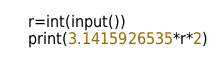<code> <loc_0><loc_0><loc_500><loc_500><_Python_>r=int(input())
print(3.1415926535*r*2)</code> 